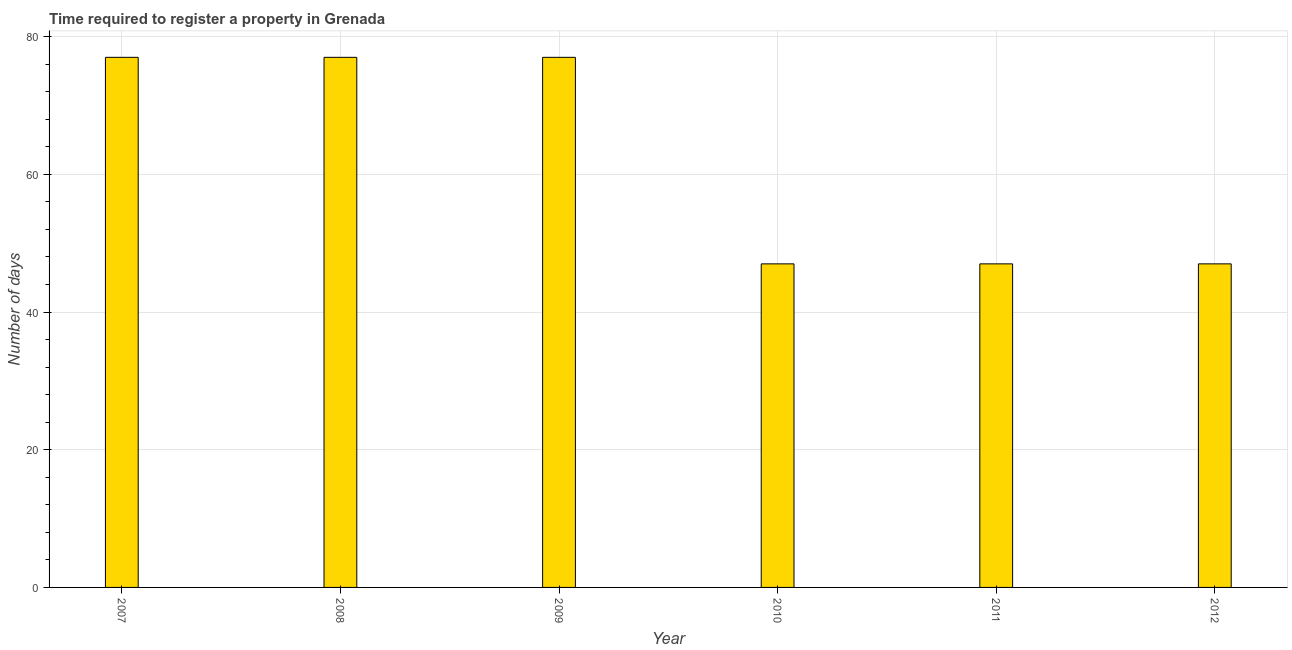Does the graph contain any zero values?
Your answer should be compact. No. What is the title of the graph?
Provide a succinct answer. Time required to register a property in Grenada. What is the label or title of the Y-axis?
Your answer should be compact. Number of days. What is the number of days required to register property in 2008?
Offer a very short reply. 77. Across all years, what is the maximum number of days required to register property?
Your answer should be compact. 77. In which year was the number of days required to register property maximum?
Offer a terse response. 2007. In which year was the number of days required to register property minimum?
Your response must be concise. 2010. What is the sum of the number of days required to register property?
Give a very brief answer. 372. What is the difference between the number of days required to register property in 2007 and 2009?
Offer a very short reply. 0. What is the average number of days required to register property per year?
Your response must be concise. 62. Is the difference between the number of days required to register property in 2008 and 2011 greater than the difference between any two years?
Provide a short and direct response. Yes. What is the difference between the highest and the lowest number of days required to register property?
Give a very brief answer. 30. How many bars are there?
Give a very brief answer. 6. Are all the bars in the graph horizontal?
Your response must be concise. No. What is the difference between two consecutive major ticks on the Y-axis?
Your response must be concise. 20. What is the Number of days in 2008?
Offer a very short reply. 77. What is the Number of days of 2012?
Make the answer very short. 47. What is the difference between the Number of days in 2007 and 2010?
Give a very brief answer. 30. What is the difference between the Number of days in 2007 and 2011?
Your response must be concise. 30. What is the difference between the Number of days in 2007 and 2012?
Your answer should be very brief. 30. What is the difference between the Number of days in 2008 and 2009?
Provide a succinct answer. 0. What is the difference between the Number of days in 2008 and 2010?
Ensure brevity in your answer.  30. What is the difference between the Number of days in 2008 and 2011?
Your response must be concise. 30. What is the difference between the Number of days in 2009 and 2010?
Give a very brief answer. 30. What is the difference between the Number of days in 2010 and 2011?
Your response must be concise. 0. What is the difference between the Number of days in 2011 and 2012?
Provide a short and direct response. 0. What is the ratio of the Number of days in 2007 to that in 2008?
Your answer should be very brief. 1. What is the ratio of the Number of days in 2007 to that in 2010?
Your response must be concise. 1.64. What is the ratio of the Number of days in 2007 to that in 2011?
Make the answer very short. 1.64. What is the ratio of the Number of days in 2007 to that in 2012?
Ensure brevity in your answer.  1.64. What is the ratio of the Number of days in 2008 to that in 2009?
Your answer should be compact. 1. What is the ratio of the Number of days in 2008 to that in 2010?
Your answer should be compact. 1.64. What is the ratio of the Number of days in 2008 to that in 2011?
Your answer should be compact. 1.64. What is the ratio of the Number of days in 2008 to that in 2012?
Give a very brief answer. 1.64. What is the ratio of the Number of days in 2009 to that in 2010?
Your answer should be compact. 1.64. What is the ratio of the Number of days in 2009 to that in 2011?
Your answer should be very brief. 1.64. What is the ratio of the Number of days in 2009 to that in 2012?
Provide a short and direct response. 1.64. What is the ratio of the Number of days in 2010 to that in 2011?
Offer a very short reply. 1. What is the ratio of the Number of days in 2010 to that in 2012?
Provide a succinct answer. 1. What is the ratio of the Number of days in 2011 to that in 2012?
Make the answer very short. 1. 